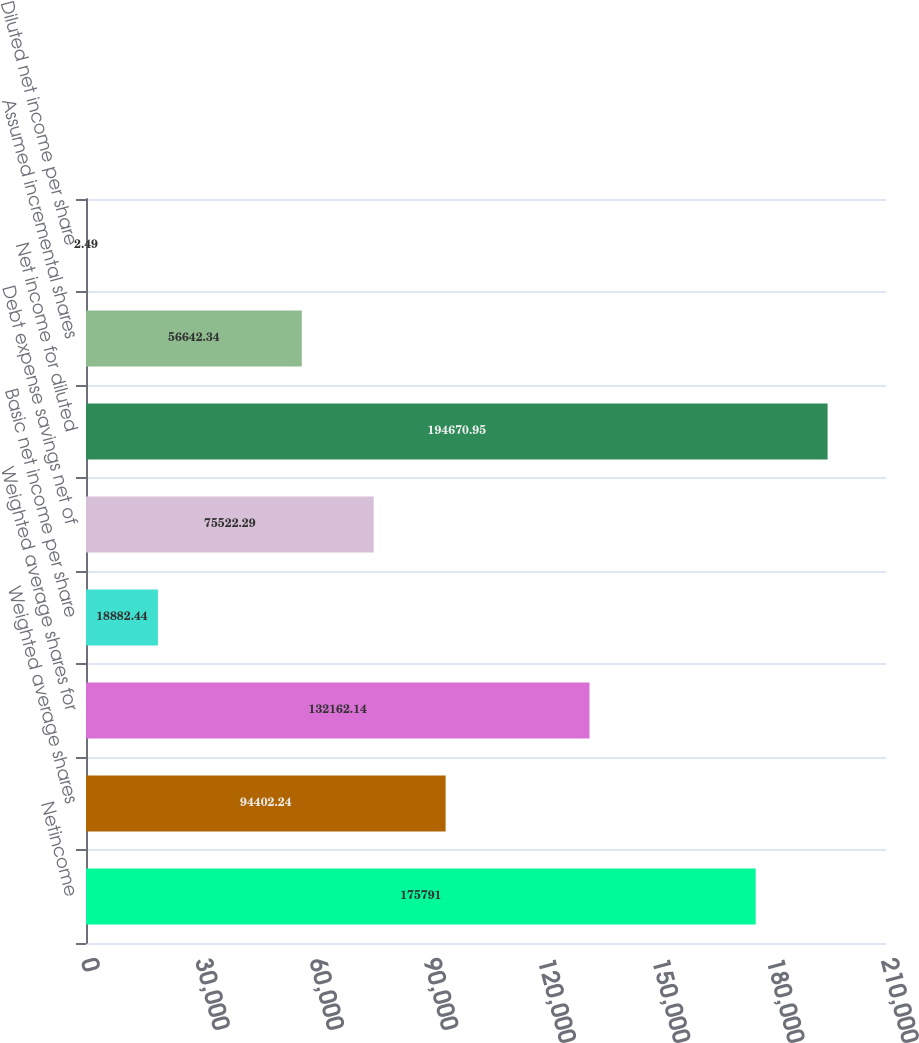Convert chart. <chart><loc_0><loc_0><loc_500><loc_500><bar_chart><fcel>Netincome<fcel>Weighted average shares<fcel>Weighted average shares for<fcel>Basic net income per share<fcel>Debt expense savings net of<fcel>Net income for diluted<fcel>Assumed incremental shares<fcel>Diluted net income per share<nl><fcel>175791<fcel>94402.2<fcel>132162<fcel>18882.4<fcel>75522.3<fcel>194671<fcel>56642.3<fcel>2.49<nl></chart> 